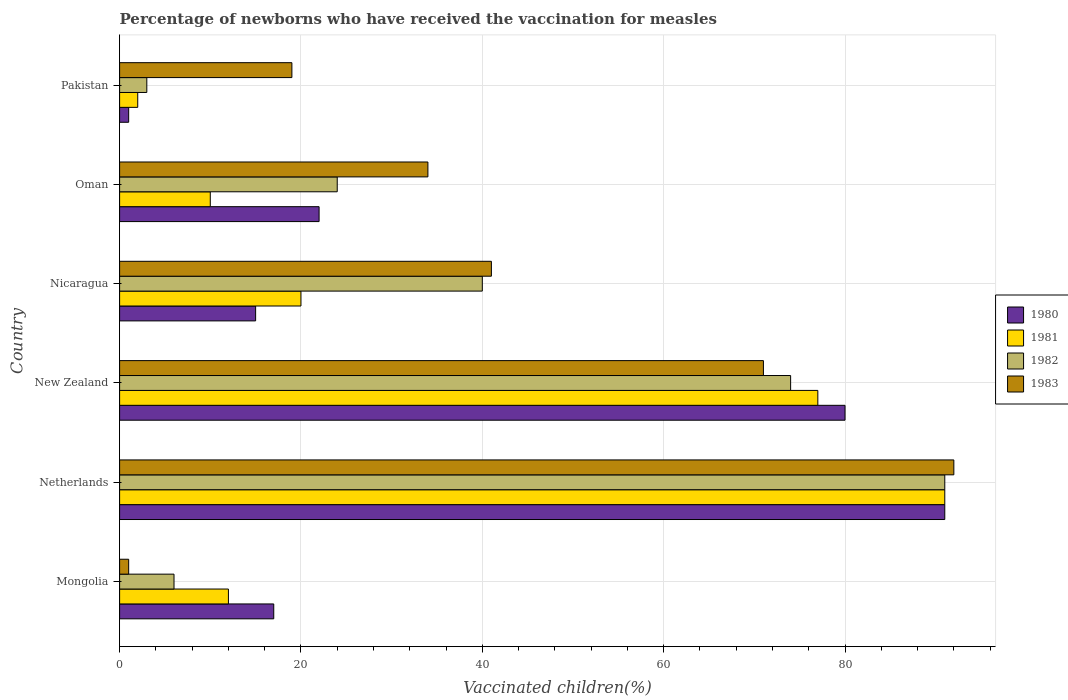How many groups of bars are there?
Your answer should be compact. 6. How many bars are there on the 2nd tick from the top?
Your response must be concise. 4. What is the label of the 6th group of bars from the top?
Provide a short and direct response. Mongolia. What is the percentage of vaccinated children in 1980 in New Zealand?
Your answer should be very brief. 80. Across all countries, what is the maximum percentage of vaccinated children in 1981?
Your answer should be very brief. 91. In which country was the percentage of vaccinated children in 1982 maximum?
Your answer should be compact. Netherlands. In which country was the percentage of vaccinated children in 1981 minimum?
Offer a terse response. Pakistan. What is the total percentage of vaccinated children in 1980 in the graph?
Provide a succinct answer. 226. What is the difference between the percentage of vaccinated children in 1981 in Nicaragua and the percentage of vaccinated children in 1982 in New Zealand?
Make the answer very short. -54. What is the difference between the percentage of vaccinated children in 1982 and percentage of vaccinated children in 1983 in Pakistan?
Give a very brief answer. -16. In how many countries, is the percentage of vaccinated children in 1983 greater than 80 %?
Give a very brief answer. 1. What is the ratio of the percentage of vaccinated children in 1981 in Netherlands to that in Nicaragua?
Offer a terse response. 4.55. Is the percentage of vaccinated children in 1980 in Mongolia less than that in Netherlands?
Make the answer very short. Yes. Is the difference between the percentage of vaccinated children in 1982 in Netherlands and Pakistan greater than the difference between the percentage of vaccinated children in 1983 in Netherlands and Pakistan?
Your response must be concise. Yes. What is the difference between the highest and the second highest percentage of vaccinated children in 1981?
Make the answer very short. 14. Is the sum of the percentage of vaccinated children in 1980 in New Zealand and Pakistan greater than the maximum percentage of vaccinated children in 1983 across all countries?
Ensure brevity in your answer.  No. Is it the case that in every country, the sum of the percentage of vaccinated children in 1982 and percentage of vaccinated children in 1980 is greater than the sum of percentage of vaccinated children in 1981 and percentage of vaccinated children in 1983?
Provide a short and direct response. No. What does the 3rd bar from the top in Nicaragua represents?
Ensure brevity in your answer.  1981. Is it the case that in every country, the sum of the percentage of vaccinated children in 1980 and percentage of vaccinated children in 1982 is greater than the percentage of vaccinated children in 1981?
Offer a very short reply. Yes. How many bars are there?
Give a very brief answer. 24. How many countries are there in the graph?
Give a very brief answer. 6. Are the values on the major ticks of X-axis written in scientific E-notation?
Your answer should be compact. No. Does the graph contain any zero values?
Provide a short and direct response. No. Does the graph contain grids?
Your response must be concise. Yes. Where does the legend appear in the graph?
Offer a very short reply. Center right. How are the legend labels stacked?
Give a very brief answer. Vertical. What is the title of the graph?
Provide a succinct answer. Percentage of newborns who have received the vaccination for measles. What is the label or title of the X-axis?
Give a very brief answer. Vaccinated children(%). What is the label or title of the Y-axis?
Your answer should be very brief. Country. What is the Vaccinated children(%) in 1980 in Netherlands?
Offer a terse response. 91. What is the Vaccinated children(%) of 1981 in Netherlands?
Make the answer very short. 91. What is the Vaccinated children(%) of 1982 in Netherlands?
Ensure brevity in your answer.  91. What is the Vaccinated children(%) of 1983 in Netherlands?
Your response must be concise. 92. What is the Vaccinated children(%) in 1980 in New Zealand?
Give a very brief answer. 80. What is the Vaccinated children(%) in 1983 in Nicaragua?
Ensure brevity in your answer.  41. What is the Vaccinated children(%) in 1980 in Oman?
Your answer should be very brief. 22. What is the Vaccinated children(%) in 1981 in Oman?
Your answer should be compact. 10. Across all countries, what is the maximum Vaccinated children(%) in 1980?
Make the answer very short. 91. Across all countries, what is the maximum Vaccinated children(%) of 1981?
Make the answer very short. 91. Across all countries, what is the maximum Vaccinated children(%) in 1982?
Your answer should be very brief. 91. Across all countries, what is the maximum Vaccinated children(%) in 1983?
Ensure brevity in your answer.  92. Across all countries, what is the minimum Vaccinated children(%) in 1983?
Your response must be concise. 1. What is the total Vaccinated children(%) in 1980 in the graph?
Ensure brevity in your answer.  226. What is the total Vaccinated children(%) in 1981 in the graph?
Ensure brevity in your answer.  212. What is the total Vaccinated children(%) in 1982 in the graph?
Keep it short and to the point. 238. What is the total Vaccinated children(%) of 1983 in the graph?
Offer a terse response. 258. What is the difference between the Vaccinated children(%) of 1980 in Mongolia and that in Netherlands?
Provide a succinct answer. -74. What is the difference between the Vaccinated children(%) of 1981 in Mongolia and that in Netherlands?
Give a very brief answer. -79. What is the difference between the Vaccinated children(%) in 1982 in Mongolia and that in Netherlands?
Make the answer very short. -85. What is the difference between the Vaccinated children(%) of 1983 in Mongolia and that in Netherlands?
Your answer should be very brief. -91. What is the difference between the Vaccinated children(%) of 1980 in Mongolia and that in New Zealand?
Offer a very short reply. -63. What is the difference between the Vaccinated children(%) of 1981 in Mongolia and that in New Zealand?
Your response must be concise. -65. What is the difference between the Vaccinated children(%) of 1982 in Mongolia and that in New Zealand?
Provide a short and direct response. -68. What is the difference between the Vaccinated children(%) of 1983 in Mongolia and that in New Zealand?
Your answer should be very brief. -70. What is the difference between the Vaccinated children(%) in 1981 in Mongolia and that in Nicaragua?
Provide a short and direct response. -8. What is the difference between the Vaccinated children(%) in 1982 in Mongolia and that in Nicaragua?
Your answer should be compact. -34. What is the difference between the Vaccinated children(%) in 1983 in Mongolia and that in Nicaragua?
Your response must be concise. -40. What is the difference between the Vaccinated children(%) in 1981 in Mongolia and that in Oman?
Your answer should be compact. 2. What is the difference between the Vaccinated children(%) in 1982 in Mongolia and that in Oman?
Make the answer very short. -18. What is the difference between the Vaccinated children(%) of 1983 in Mongolia and that in Oman?
Your answer should be very brief. -33. What is the difference between the Vaccinated children(%) of 1980 in Mongolia and that in Pakistan?
Make the answer very short. 16. What is the difference between the Vaccinated children(%) in 1981 in Mongolia and that in Pakistan?
Provide a succinct answer. 10. What is the difference between the Vaccinated children(%) of 1981 in Netherlands and that in New Zealand?
Provide a short and direct response. 14. What is the difference between the Vaccinated children(%) of 1982 in Netherlands and that in New Zealand?
Provide a succinct answer. 17. What is the difference between the Vaccinated children(%) of 1980 in Netherlands and that in Nicaragua?
Make the answer very short. 76. What is the difference between the Vaccinated children(%) in 1982 in Netherlands and that in Nicaragua?
Offer a very short reply. 51. What is the difference between the Vaccinated children(%) of 1983 in Netherlands and that in Nicaragua?
Give a very brief answer. 51. What is the difference between the Vaccinated children(%) in 1982 in Netherlands and that in Oman?
Give a very brief answer. 67. What is the difference between the Vaccinated children(%) in 1980 in Netherlands and that in Pakistan?
Give a very brief answer. 90. What is the difference between the Vaccinated children(%) of 1981 in Netherlands and that in Pakistan?
Offer a very short reply. 89. What is the difference between the Vaccinated children(%) in 1981 in New Zealand and that in Nicaragua?
Offer a very short reply. 57. What is the difference between the Vaccinated children(%) in 1982 in New Zealand and that in Nicaragua?
Offer a terse response. 34. What is the difference between the Vaccinated children(%) of 1983 in New Zealand and that in Nicaragua?
Keep it short and to the point. 30. What is the difference between the Vaccinated children(%) of 1980 in New Zealand and that in Oman?
Provide a short and direct response. 58. What is the difference between the Vaccinated children(%) in 1982 in New Zealand and that in Oman?
Keep it short and to the point. 50. What is the difference between the Vaccinated children(%) of 1980 in New Zealand and that in Pakistan?
Give a very brief answer. 79. What is the difference between the Vaccinated children(%) of 1982 in New Zealand and that in Pakistan?
Your response must be concise. 71. What is the difference between the Vaccinated children(%) of 1983 in New Zealand and that in Pakistan?
Give a very brief answer. 52. What is the difference between the Vaccinated children(%) of 1980 in Nicaragua and that in Oman?
Your response must be concise. -7. What is the difference between the Vaccinated children(%) in 1981 in Nicaragua and that in Oman?
Ensure brevity in your answer.  10. What is the difference between the Vaccinated children(%) in 1981 in Nicaragua and that in Pakistan?
Give a very brief answer. 18. What is the difference between the Vaccinated children(%) in 1982 in Nicaragua and that in Pakistan?
Offer a very short reply. 37. What is the difference between the Vaccinated children(%) in 1981 in Oman and that in Pakistan?
Offer a terse response. 8. What is the difference between the Vaccinated children(%) in 1983 in Oman and that in Pakistan?
Offer a terse response. 15. What is the difference between the Vaccinated children(%) in 1980 in Mongolia and the Vaccinated children(%) in 1981 in Netherlands?
Your answer should be compact. -74. What is the difference between the Vaccinated children(%) in 1980 in Mongolia and the Vaccinated children(%) in 1982 in Netherlands?
Your answer should be compact. -74. What is the difference between the Vaccinated children(%) in 1980 in Mongolia and the Vaccinated children(%) in 1983 in Netherlands?
Your answer should be compact. -75. What is the difference between the Vaccinated children(%) of 1981 in Mongolia and the Vaccinated children(%) of 1982 in Netherlands?
Your response must be concise. -79. What is the difference between the Vaccinated children(%) in 1981 in Mongolia and the Vaccinated children(%) in 1983 in Netherlands?
Give a very brief answer. -80. What is the difference between the Vaccinated children(%) in 1982 in Mongolia and the Vaccinated children(%) in 1983 in Netherlands?
Give a very brief answer. -86. What is the difference between the Vaccinated children(%) of 1980 in Mongolia and the Vaccinated children(%) of 1981 in New Zealand?
Give a very brief answer. -60. What is the difference between the Vaccinated children(%) of 1980 in Mongolia and the Vaccinated children(%) of 1982 in New Zealand?
Offer a terse response. -57. What is the difference between the Vaccinated children(%) in 1980 in Mongolia and the Vaccinated children(%) in 1983 in New Zealand?
Ensure brevity in your answer.  -54. What is the difference between the Vaccinated children(%) of 1981 in Mongolia and the Vaccinated children(%) of 1982 in New Zealand?
Keep it short and to the point. -62. What is the difference between the Vaccinated children(%) of 1981 in Mongolia and the Vaccinated children(%) of 1983 in New Zealand?
Provide a succinct answer. -59. What is the difference between the Vaccinated children(%) of 1982 in Mongolia and the Vaccinated children(%) of 1983 in New Zealand?
Make the answer very short. -65. What is the difference between the Vaccinated children(%) of 1980 in Mongolia and the Vaccinated children(%) of 1981 in Nicaragua?
Your answer should be compact. -3. What is the difference between the Vaccinated children(%) in 1982 in Mongolia and the Vaccinated children(%) in 1983 in Nicaragua?
Provide a succinct answer. -35. What is the difference between the Vaccinated children(%) of 1980 in Mongolia and the Vaccinated children(%) of 1982 in Oman?
Make the answer very short. -7. What is the difference between the Vaccinated children(%) of 1981 in Mongolia and the Vaccinated children(%) of 1983 in Oman?
Provide a short and direct response. -22. What is the difference between the Vaccinated children(%) in 1982 in Mongolia and the Vaccinated children(%) in 1983 in Oman?
Your answer should be very brief. -28. What is the difference between the Vaccinated children(%) of 1980 in Mongolia and the Vaccinated children(%) of 1981 in Pakistan?
Provide a short and direct response. 15. What is the difference between the Vaccinated children(%) of 1981 in Mongolia and the Vaccinated children(%) of 1983 in Pakistan?
Keep it short and to the point. -7. What is the difference between the Vaccinated children(%) of 1980 in Netherlands and the Vaccinated children(%) of 1982 in New Zealand?
Your answer should be very brief. 17. What is the difference between the Vaccinated children(%) of 1980 in Netherlands and the Vaccinated children(%) of 1981 in Nicaragua?
Your answer should be very brief. 71. What is the difference between the Vaccinated children(%) of 1980 in Netherlands and the Vaccinated children(%) of 1982 in Nicaragua?
Your answer should be very brief. 51. What is the difference between the Vaccinated children(%) of 1982 in Netherlands and the Vaccinated children(%) of 1983 in Nicaragua?
Make the answer very short. 50. What is the difference between the Vaccinated children(%) of 1980 in Netherlands and the Vaccinated children(%) of 1981 in Oman?
Your answer should be compact. 81. What is the difference between the Vaccinated children(%) in 1980 in Netherlands and the Vaccinated children(%) in 1983 in Oman?
Give a very brief answer. 57. What is the difference between the Vaccinated children(%) in 1980 in Netherlands and the Vaccinated children(%) in 1981 in Pakistan?
Ensure brevity in your answer.  89. What is the difference between the Vaccinated children(%) of 1981 in Netherlands and the Vaccinated children(%) of 1982 in Pakistan?
Offer a terse response. 88. What is the difference between the Vaccinated children(%) of 1980 in New Zealand and the Vaccinated children(%) of 1981 in Nicaragua?
Provide a succinct answer. 60. What is the difference between the Vaccinated children(%) in 1981 in New Zealand and the Vaccinated children(%) in 1982 in Nicaragua?
Provide a succinct answer. 37. What is the difference between the Vaccinated children(%) in 1981 in New Zealand and the Vaccinated children(%) in 1983 in Nicaragua?
Keep it short and to the point. 36. What is the difference between the Vaccinated children(%) of 1982 in New Zealand and the Vaccinated children(%) of 1983 in Nicaragua?
Your answer should be compact. 33. What is the difference between the Vaccinated children(%) in 1980 in New Zealand and the Vaccinated children(%) in 1983 in Oman?
Offer a very short reply. 46. What is the difference between the Vaccinated children(%) of 1981 in New Zealand and the Vaccinated children(%) of 1982 in Oman?
Ensure brevity in your answer.  53. What is the difference between the Vaccinated children(%) in 1981 in New Zealand and the Vaccinated children(%) in 1983 in Oman?
Provide a succinct answer. 43. What is the difference between the Vaccinated children(%) in 1980 in Nicaragua and the Vaccinated children(%) in 1981 in Oman?
Offer a terse response. 5. What is the difference between the Vaccinated children(%) of 1981 in Nicaragua and the Vaccinated children(%) of 1982 in Oman?
Your answer should be compact. -4. What is the difference between the Vaccinated children(%) in 1981 in Nicaragua and the Vaccinated children(%) in 1983 in Oman?
Your answer should be very brief. -14. What is the difference between the Vaccinated children(%) in 1981 in Nicaragua and the Vaccinated children(%) in 1982 in Pakistan?
Keep it short and to the point. 17. What is the difference between the Vaccinated children(%) of 1980 in Oman and the Vaccinated children(%) of 1982 in Pakistan?
Provide a succinct answer. 19. What is the difference between the Vaccinated children(%) in 1980 in Oman and the Vaccinated children(%) in 1983 in Pakistan?
Offer a very short reply. 3. What is the difference between the Vaccinated children(%) in 1981 in Oman and the Vaccinated children(%) in 1982 in Pakistan?
Keep it short and to the point. 7. What is the difference between the Vaccinated children(%) in 1981 in Oman and the Vaccinated children(%) in 1983 in Pakistan?
Offer a very short reply. -9. What is the average Vaccinated children(%) in 1980 per country?
Your response must be concise. 37.67. What is the average Vaccinated children(%) of 1981 per country?
Your answer should be very brief. 35.33. What is the average Vaccinated children(%) of 1982 per country?
Provide a short and direct response. 39.67. What is the average Vaccinated children(%) in 1983 per country?
Offer a terse response. 43. What is the difference between the Vaccinated children(%) of 1980 and Vaccinated children(%) of 1981 in Mongolia?
Ensure brevity in your answer.  5. What is the difference between the Vaccinated children(%) in 1980 and Vaccinated children(%) in 1982 in Mongolia?
Provide a succinct answer. 11. What is the difference between the Vaccinated children(%) in 1982 and Vaccinated children(%) in 1983 in Mongolia?
Offer a terse response. 5. What is the difference between the Vaccinated children(%) in 1980 and Vaccinated children(%) in 1982 in Netherlands?
Provide a short and direct response. 0. What is the difference between the Vaccinated children(%) of 1980 and Vaccinated children(%) of 1983 in Netherlands?
Make the answer very short. -1. What is the difference between the Vaccinated children(%) of 1981 and Vaccinated children(%) of 1982 in Netherlands?
Your answer should be very brief. 0. What is the difference between the Vaccinated children(%) of 1981 and Vaccinated children(%) of 1983 in Netherlands?
Your response must be concise. -1. What is the difference between the Vaccinated children(%) in 1982 and Vaccinated children(%) in 1983 in Netherlands?
Offer a terse response. -1. What is the difference between the Vaccinated children(%) in 1980 and Vaccinated children(%) in 1982 in New Zealand?
Offer a terse response. 6. What is the difference between the Vaccinated children(%) of 1982 and Vaccinated children(%) of 1983 in New Zealand?
Give a very brief answer. 3. What is the difference between the Vaccinated children(%) in 1980 and Vaccinated children(%) in 1982 in Nicaragua?
Give a very brief answer. -25. What is the difference between the Vaccinated children(%) of 1981 and Vaccinated children(%) of 1982 in Nicaragua?
Your answer should be very brief. -20. What is the difference between the Vaccinated children(%) of 1982 and Vaccinated children(%) of 1983 in Nicaragua?
Provide a succinct answer. -1. What is the difference between the Vaccinated children(%) of 1981 and Vaccinated children(%) of 1982 in Oman?
Your answer should be compact. -14. What is the difference between the Vaccinated children(%) in 1981 and Vaccinated children(%) in 1983 in Oman?
Offer a very short reply. -24. What is the difference between the Vaccinated children(%) in 1980 and Vaccinated children(%) in 1981 in Pakistan?
Provide a succinct answer. -1. What is the difference between the Vaccinated children(%) in 1980 and Vaccinated children(%) in 1982 in Pakistan?
Your answer should be compact. -2. What is the difference between the Vaccinated children(%) in 1980 and Vaccinated children(%) in 1983 in Pakistan?
Your answer should be very brief. -18. What is the difference between the Vaccinated children(%) of 1981 and Vaccinated children(%) of 1982 in Pakistan?
Offer a terse response. -1. What is the difference between the Vaccinated children(%) in 1981 and Vaccinated children(%) in 1983 in Pakistan?
Ensure brevity in your answer.  -17. What is the difference between the Vaccinated children(%) of 1982 and Vaccinated children(%) of 1983 in Pakistan?
Offer a terse response. -16. What is the ratio of the Vaccinated children(%) of 1980 in Mongolia to that in Netherlands?
Provide a short and direct response. 0.19. What is the ratio of the Vaccinated children(%) in 1981 in Mongolia to that in Netherlands?
Make the answer very short. 0.13. What is the ratio of the Vaccinated children(%) of 1982 in Mongolia to that in Netherlands?
Provide a short and direct response. 0.07. What is the ratio of the Vaccinated children(%) in 1983 in Mongolia to that in Netherlands?
Provide a short and direct response. 0.01. What is the ratio of the Vaccinated children(%) of 1980 in Mongolia to that in New Zealand?
Make the answer very short. 0.21. What is the ratio of the Vaccinated children(%) of 1981 in Mongolia to that in New Zealand?
Keep it short and to the point. 0.16. What is the ratio of the Vaccinated children(%) in 1982 in Mongolia to that in New Zealand?
Ensure brevity in your answer.  0.08. What is the ratio of the Vaccinated children(%) in 1983 in Mongolia to that in New Zealand?
Provide a short and direct response. 0.01. What is the ratio of the Vaccinated children(%) of 1980 in Mongolia to that in Nicaragua?
Offer a very short reply. 1.13. What is the ratio of the Vaccinated children(%) of 1982 in Mongolia to that in Nicaragua?
Provide a succinct answer. 0.15. What is the ratio of the Vaccinated children(%) of 1983 in Mongolia to that in Nicaragua?
Keep it short and to the point. 0.02. What is the ratio of the Vaccinated children(%) in 1980 in Mongolia to that in Oman?
Keep it short and to the point. 0.77. What is the ratio of the Vaccinated children(%) of 1981 in Mongolia to that in Oman?
Your answer should be very brief. 1.2. What is the ratio of the Vaccinated children(%) of 1982 in Mongolia to that in Oman?
Ensure brevity in your answer.  0.25. What is the ratio of the Vaccinated children(%) of 1983 in Mongolia to that in Oman?
Ensure brevity in your answer.  0.03. What is the ratio of the Vaccinated children(%) of 1983 in Mongolia to that in Pakistan?
Keep it short and to the point. 0.05. What is the ratio of the Vaccinated children(%) of 1980 in Netherlands to that in New Zealand?
Offer a very short reply. 1.14. What is the ratio of the Vaccinated children(%) in 1981 in Netherlands to that in New Zealand?
Provide a short and direct response. 1.18. What is the ratio of the Vaccinated children(%) in 1982 in Netherlands to that in New Zealand?
Your response must be concise. 1.23. What is the ratio of the Vaccinated children(%) of 1983 in Netherlands to that in New Zealand?
Ensure brevity in your answer.  1.3. What is the ratio of the Vaccinated children(%) in 1980 in Netherlands to that in Nicaragua?
Ensure brevity in your answer.  6.07. What is the ratio of the Vaccinated children(%) of 1981 in Netherlands to that in Nicaragua?
Provide a succinct answer. 4.55. What is the ratio of the Vaccinated children(%) in 1982 in Netherlands to that in Nicaragua?
Your answer should be compact. 2.27. What is the ratio of the Vaccinated children(%) of 1983 in Netherlands to that in Nicaragua?
Your response must be concise. 2.24. What is the ratio of the Vaccinated children(%) of 1980 in Netherlands to that in Oman?
Give a very brief answer. 4.14. What is the ratio of the Vaccinated children(%) in 1981 in Netherlands to that in Oman?
Your answer should be compact. 9.1. What is the ratio of the Vaccinated children(%) in 1982 in Netherlands to that in Oman?
Your response must be concise. 3.79. What is the ratio of the Vaccinated children(%) of 1983 in Netherlands to that in Oman?
Offer a terse response. 2.71. What is the ratio of the Vaccinated children(%) of 1980 in Netherlands to that in Pakistan?
Provide a succinct answer. 91. What is the ratio of the Vaccinated children(%) in 1981 in Netherlands to that in Pakistan?
Your answer should be compact. 45.5. What is the ratio of the Vaccinated children(%) in 1982 in Netherlands to that in Pakistan?
Keep it short and to the point. 30.33. What is the ratio of the Vaccinated children(%) of 1983 in Netherlands to that in Pakistan?
Offer a very short reply. 4.84. What is the ratio of the Vaccinated children(%) of 1980 in New Zealand to that in Nicaragua?
Make the answer very short. 5.33. What is the ratio of the Vaccinated children(%) in 1981 in New Zealand to that in Nicaragua?
Ensure brevity in your answer.  3.85. What is the ratio of the Vaccinated children(%) in 1982 in New Zealand to that in Nicaragua?
Your response must be concise. 1.85. What is the ratio of the Vaccinated children(%) in 1983 in New Zealand to that in Nicaragua?
Provide a succinct answer. 1.73. What is the ratio of the Vaccinated children(%) in 1980 in New Zealand to that in Oman?
Make the answer very short. 3.64. What is the ratio of the Vaccinated children(%) in 1981 in New Zealand to that in Oman?
Ensure brevity in your answer.  7.7. What is the ratio of the Vaccinated children(%) in 1982 in New Zealand to that in Oman?
Your answer should be compact. 3.08. What is the ratio of the Vaccinated children(%) in 1983 in New Zealand to that in Oman?
Your answer should be compact. 2.09. What is the ratio of the Vaccinated children(%) in 1980 in New Zealand to that in Pakistan?
Make the answer very short. 80. What is the ratio of the Vaccinated children(%) in 1981 in New Zealand to that in Pakistan?
Your response must be concise. 38.5. What is the ratio of the Vaccinated children(%) in 1982 in New Zealand to that in Pakistan?
Ensure brevity in your answer.  24.67. What is the ratio of the Vaccinated children(%) of 1983 in New Zealand to that in Pakistan?
Your answer should be compact. 3.74. What is the ratio of the Vaccinated children(%) of 1980 in Nicaragua to that in Oman?
Provide a short and direct response. 0.68. What is the ratio of the Vaccinated children(%) of 1982 in Nicaragua to that in Oman?
Your response must be concise. 1.67. What is the ratio of the Vaccinated children(%) of 1983 in Nicaragua to that in Oman?
Your response must be concise. 1.21. What is the ratio of the Vaccinated children(%) of 1982 in Nicaragua to that in Pakistan?
Your answer should be very brief. 13.33. What is the ratio of the Vaccinated children(%) of 1983 in Nicaragua to that in Pakistan?
Provide a short and direct response. 2.16. What is the ratio of the Vaccinated children(%) of 1982 in Oman to that in Pakistan?
Make the answer very short. 8. What is the ratio of the Vaccinated children(%) of 1983 in Oman to that in Pakistan?
Ensure brevity in your answer.  1.79. What is the difference between the highest and the second highest Vaccinated children(%) of 1982?
Your answer should be compact. 17. What is the difference between the highest and the lowest Vaccinated children(%) in 1981?
Your answer should be compact. 89. What is the difference between the highest and the lowest Vaccinated children(%) of 1983?
Offer a terse response. 91. 